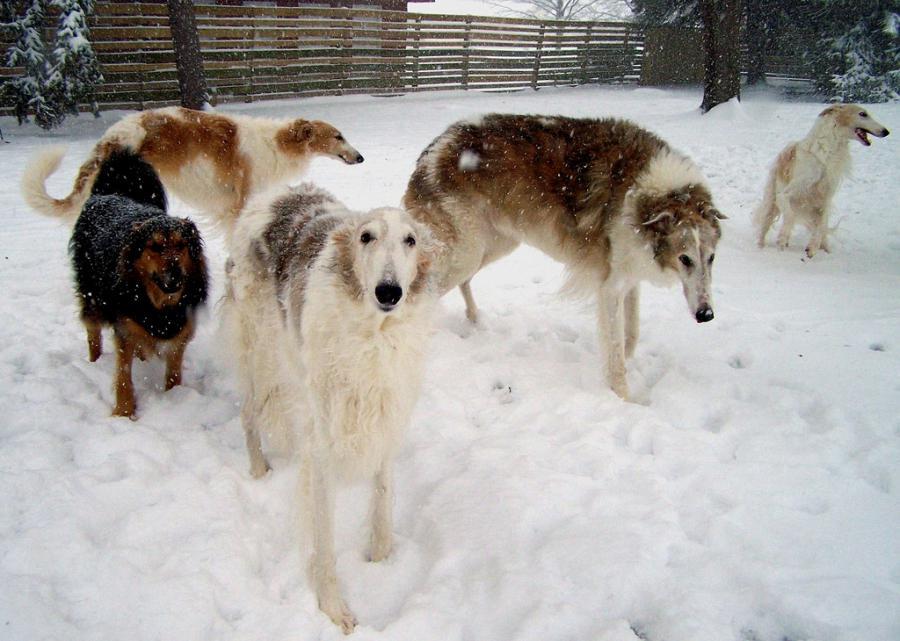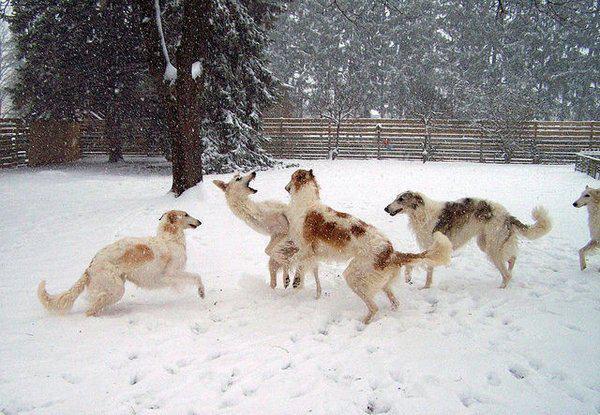The first image is the image on the left, the second image is the image on the right. Examine the images to the left and right. Is the description "Each image features one bounding dog, with one image showing a dog on a beach and the other a dog on a grassy field." accurate? Answer yes or no. No. The first image is the image on the left, the second image is the image on the right. Assess this claim about the two images: "The right image contains at least one dog that is surrounded by snow.". Correct or not? Answer yes or no. Yes. 